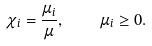Convert formula to latex. <formula><loc_0><loc_0><loc_500><loc_500>\chi _ { i } = \frac { \mu _ { i } } { \mu } , \quad \mu _ { i } \geq 0 .</formula> 